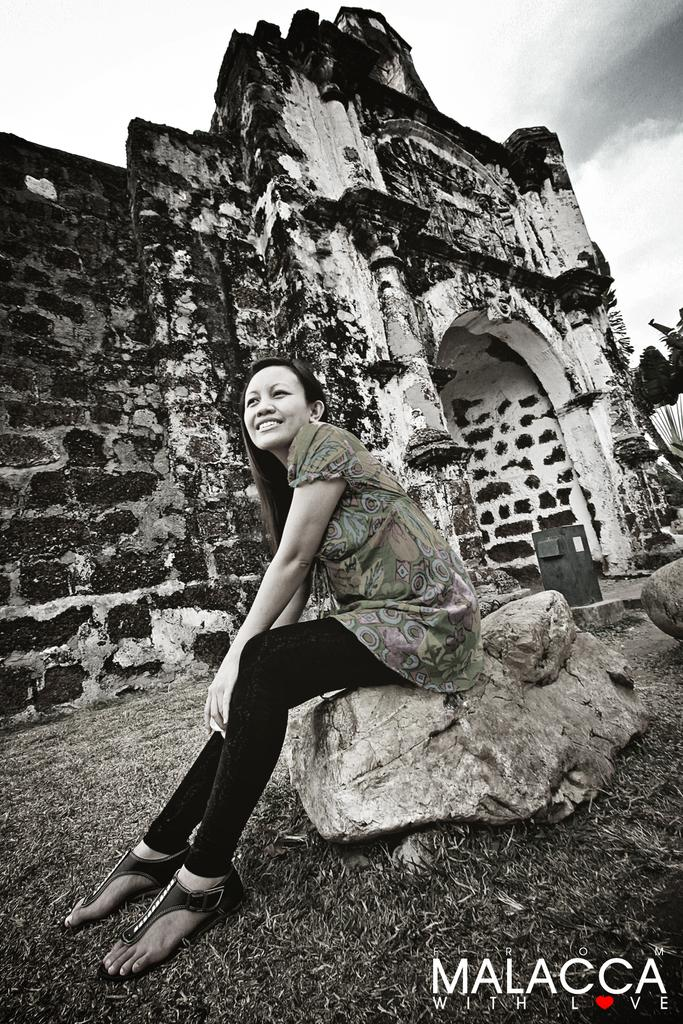What is the woman doing in the image? The woman is sitting on a stone in the image. What can be seen in the background of the image? There is a building structure and the sky visible in the background of the image. How many dimes can be seen on the stone where the woman is sitting? There are no dimes visible on the stone where the woman is sitting in the image. 